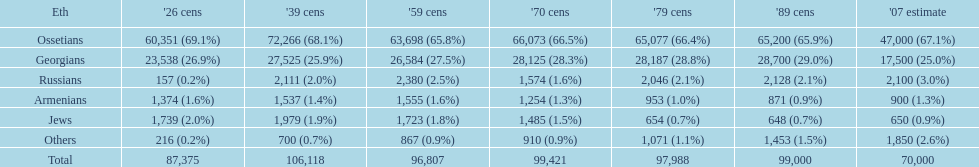Give me the full table as a dictionary. {'header': ['Eth', "'26 cens", "'39 cens", "'59 cens", "'70 cens", "'79 cens", "'89 cens", "'07 estimate"], 'rows': [['Ossetians', '60,351 (69.1%)', '72,266 (68.1%)', '63,698 (65.8%)', '66,073 (66.5%)', '65,077 (66.4%)', '65,200 (65.9%)', '47,000 (67.1%)'], ['Georgians', '23,538 (26.9%)', '27,525 (25.9%)', '26,584 (27.5%)', '28,125 (28.3%)', '28,187 (28.8%)', '28,700 (29.0%)', '17,500 (25.0%)'], ['Russians', '157 (0.2%)', '2,111 (2.0%)', '2,380 (2.5%)', '1,574 (1.6%)', '2,046 (2.1%)', '2,128 (2.1%)', '2,100 (3.0%)'], ['Armenians', '1,374 (1.6%)', '1,537 (1.4%)', '1,555 (1.6%)', '1,254 (1.3%)', '953 (1.0%)', '871 (0.9%)', '900 (1.3%)'], ['Jews', '1,739 (2.0%)', '1,979 (1.9%)', '1,723 (1.8%)', '1,485 (1.5%)', '654 (0.7%)', '648 (0.7%)', '650 (0.9%)'], ['Others', '216 (0.2%)', '700 (0.7%)', '867 (0.9%)', '910 (0.9%)', '1,071 (1.1%)', '1,453 (1.5%)', '1,850 (2.6%)'], ['Total', '87,375', '106,118', '96,807', '99,421', '97,988', '99,000', '70,000']]} What was the first census that saw a russian population of over 2,000? 1939 census. 